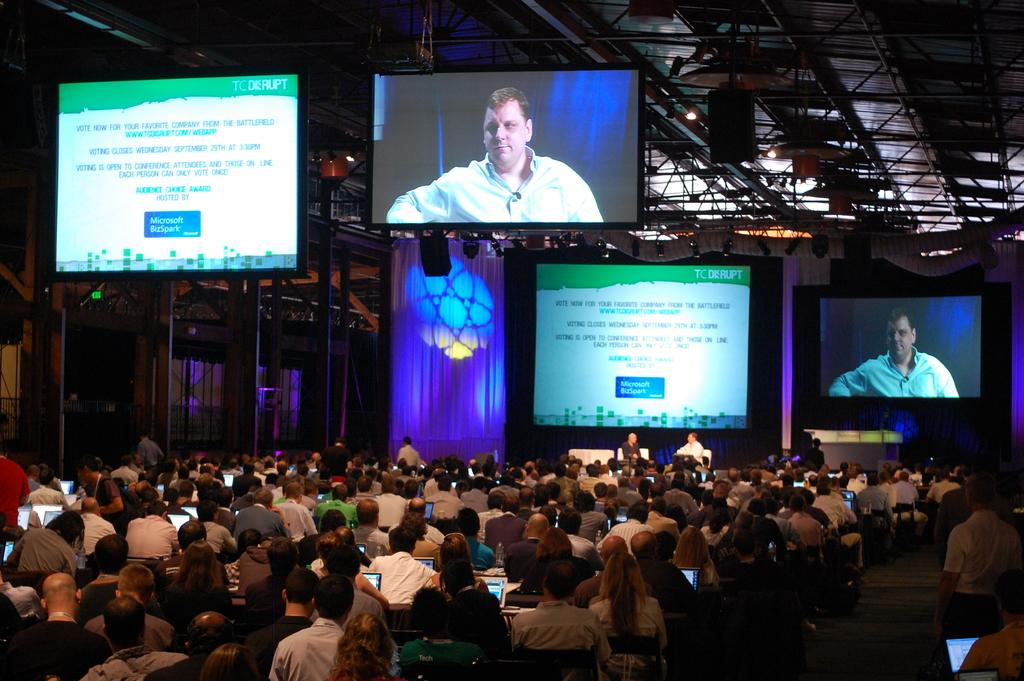<image>
Relay a brief, clear account of the picture shown. A large crowd in a conference center looks towards a screen that says "Microsoft BizSpark" 